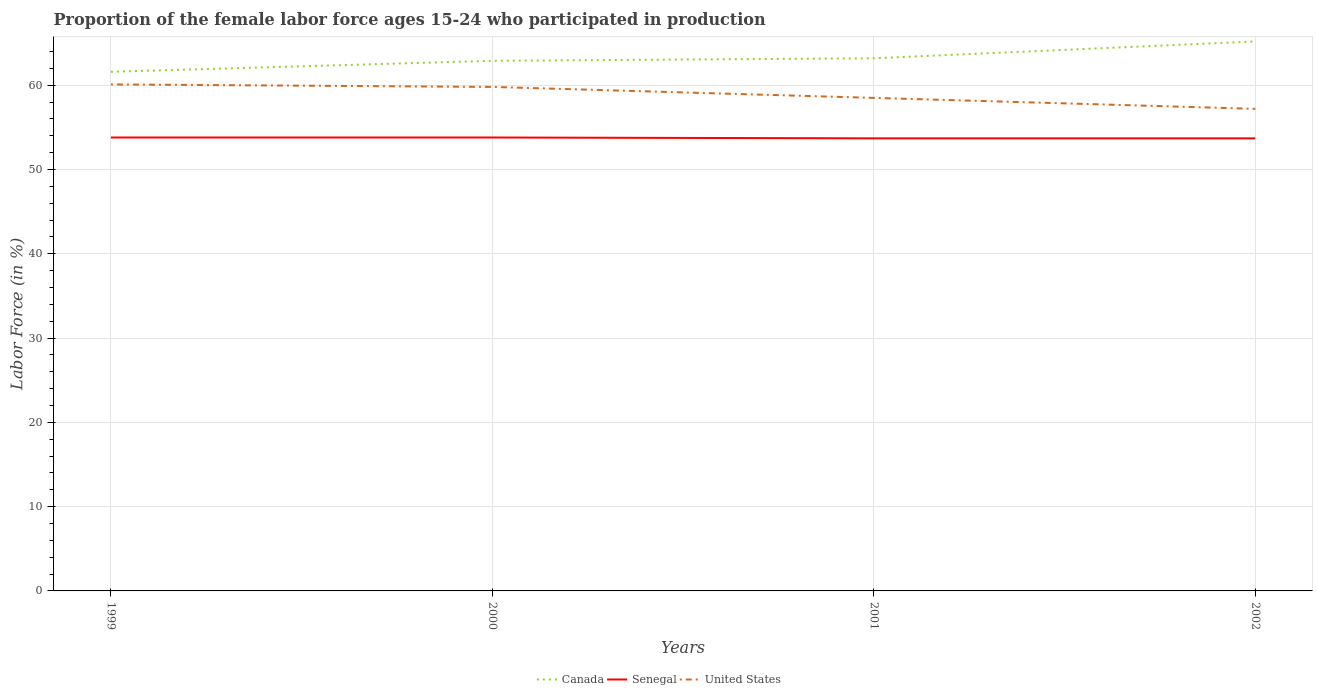Is the number of lines equal to the number of legend labels?
Offer a terse response. Yes. Across all years, what is the maximum proportion of the female labor force who participated in production in Canada?
Your answer should be very brief. 61.6. What is the total proportion of the female labor force who participated in production in Canada in the graph?
Offer a terse response. -0.3. What is the difference between the highest and the second highest proportion of the female labor force who participated in production in Canada?
Your answer should be very brief. 3.6. What is the difference between the highest and the lowest proportion of the female labor force who participated in production in United States?
Make the answer very short. 2. Is the proportion of the female labor force who participated in production in Senegal strictly greater than the proportion of the female labor force who participated in production in Canada over the years?
Provide a short and direct response. Yes. How many lines are there?
Provide a short and direct response. 3. What is the difference between two consecutive major ticks on the Y-axis?
Keep it short and to the point. 10. Are the values on the major ticks of Y-axis written in scientific E-notation?
Your answer should be compact. No. What is the title of the graph?
Provide a short and direct response. Proportion of the female labor force ages 15-24 who participated in production. Does "Poland" appear as one of the legend labels in the graph?
Provide a succinct answer. No. What is the label or title of the X-axis?
Offer a terse response. Years. What is the Labor Force (in %) of Canada in 1999?
Provide a succinct answer. 61.6. What is the Labor Force (in %) in Senegal in 1999?
Make the answer very short. 53.8. What is the Labor Force (in %) of United States in 1999?
Your answer should be compact. 60.1. What is the Labor Force (in %) of Canada in 2000?
Ensure brevity in your answer.  62.9. What is the Labor Force (in %) of Senegal in 2000?
Your answer should be very brief. 53.8. What is the Labor Force (in %) in United States in 2000?
Your response must be concise. 59.8. What is the Labor Force (in %) in Canada in 2001?
Ensure brevity in your answer.  63.2. What is the Labor Force (in %) of Senegal in 2001?
Make the answer very short. 53.7. What is the Labor Force (in %) in United States in 2001?
Make the answer very short. 58.5. What is the Labor Force (in %) of Canada in 2002?
Provide a short and direct response. 65.2. What is the Labor Force (in %) of Senegal in 2002?
Make the answer very short. 53.7. What is the Labor Force (in %) in United States in 2002?
Offer a very short reply. 57.2. Across all years, what is the maximum Labor Force (in %) of Canada?
Ensure brevity in your answer.  65.2. Across all years, what is the maximum Labor Force (in %) in Senegal?
Make the answer very short. 53.8. Across all years, what is the maximum Labor Force (in %) of United States?
Provide a short and direct response. 60.1. Across all years, what is the minimum Labor Force (in %) of Canada?
Keep it short and to the point. 61.6. Across all years, what is the minimum Labor Force (in %) in Senegal?
Provide a short and direct response. 53.7. Across all years, what is the minimum Labor Force (in %) in United States?
Make the answer very short. 57.2. What is the total Labor Force (in %) in Canada in the graph?
Make the answer very short. 252.9. What is the total Labor Force (in %) of Senegal in the graph?
Offer a terse response. 215. What is the total Labor Force (in %) in United States in the graph?
Offer a very short reply. 235.6. What is the difference between the Labor Force (in %) in Canada in 1999 and that in 2000?
Your answer should be compact. -1.3. What is the difference between the Labor Force (in %) of Senegal in 1999 and that in 2000?
Ensure brevity in your answer.  0. What is the difference between the Labor Force (in %) of Canada in 1999 and that in 2001?
Your response must be concise. -1.6. What is the difference between the Labor Force (in %) in United States in 1999 and that in 2001?
Your answer should be very brief. 1.6. What is the difference between the Labor Force (in %) of Senegal in 1999 and that in 2002?
Keep it short and to the point. 0.1. What is the difference between the Labor Force (in %) of Senegal in 2000 and that in 2001?
Provide a short and direct response. 0.1. What is the difference between the Labor Force (in %) in United States in 2000 and that in 2001?
Offer a terse response. 1.3. What is the difference between the Labor Force (in %) of Canada in 2000 and that in 2002?
Ensure brevity in your answer.  -2.3. What is the difference between the Labor Force (in %) in Senegal in 2000 and that in 2002?
Make the answer very short. 0.1. What is the difference between the Labor Force (in %) in United States in 2001 and that in 2002?
Give a very brief answer. 1.3. What is the difference between the Labor Force (in %) in Canada in 1999 and the Labor Force (in %) in United States in 2000?
Keep it short and to the point. 1.8. What is the difference between the Labor Force (in %) of Canada in 1999 and the Labor Force (in %) of United States in 2001?
Provide a short and direct response. 3.1. What is the difference between the Labor Force (in %) in Senegal in 1999 and the Labor Force (in %) in United States in 2001?
Your response must be concise. -4.7. What is the difference between the Labor Force (in %) of Canada in 1999 and the Labor Force (in %) of Senegal in 2002?
Provide a short and direct response. 7.9. What is the difference between the Labor Force (in %) of Canada in 2000 and the Labor Force (in %) of Senegal in 2001?
Offer a terse response. 9.2. What is the difference between the Labor Force (in %) of Canada in 2000 and the Labor Force (in %) of United States in 2001?
Offer a terse response. 4.4. What is the difference between the Labor Force (in %) in Senegal in 2000 and the Labor Force (in %) in United States in 2001?
Your response must be concise. -4.7. What is the difference between the Labor Force (in %) of Canada in 2000 and the Labor Force (in %) of Senegal in 2002?
Offer a terse response. 9.2. What is the difference between the Labor Force (in %) of Canada in 2001 and the Labor Force (in %) of Senegal in 2002?
Offer a terse response. 9.5. What is the difference between the Labor Force (in %) in Canada in 2001 and the Labor Force (in %) in United States in 2002?
Your response must be concise. 6. What is the average Labor Force (in %) of Canada per year?
Keep it short and to the point. 63.23. What is the average Labor Force (in %) of Senegal per year?
Your response must be concise. 53.75. What is the average Labor Force (in %) in United States per year?
Your answer should be compact. 58.9. In the year 1999, what is the difference between the Labor Force (in %) of Canada and Labor Force (in %) of United States?
Keep it short and to the point. 1.5. In the year 2000, what is the difference between the Labor Force (in %) in Canada and Labor Force (in %) in United States?
Offer a terse response. 3.1. In the year 2001, what is the difference between the Labor Force (in %) of Canada and Labor Force (in %) of Senegal?
Provide a short and direct response. 9.5. In the year 2001, what is the difference between the Labor Force (in %) of Canada and Labor Force (in %) of United States?
Your answer should be compact. 4.7. In the year 2002, what is the difference between the Labor Force (in %) of Canada and Labor Force (in %) of Senegal?
Give a very brief answer. 11.5. In the year 2002, what is the difference between the Labor Force (in %) of Canada and Labor Force (in %) of United States?
Provide a short and direct response. 8. What is the ratio of the Labor Force (in %) in Canada in 1999 to that in 2000?
Offer a terse response. 0.98. What is the ratio of the Labor Force (in %) in Canada in 1999 to that in 2001?
Give a very brief answer. 0.97. What is the ratio of the Labor Force (in %) of United States in 1999 to that in 2001?
Your response must be concise. 1.03. What is the ratio of the Labor Force (in %) of Canada in 1999 to that in 2002?
Offer a very short reply. 0.94. What is the ratio of the Labor Force (in %) of United States in 1999 to that in 2002?
Offer a terse response. 1.05. What is the ratio of the Labor Force (in %) of Canada in 2000 to that in 2001?
Make the answer very short. 1. What is the ratio of the Labor Force (in %) of Senegal in 2000 to that in 2001?
Your response must be concise. 1. What is the ratio of the Labor Force (in %) in United States in 2000 to that in 2001?
Your response must be concise. 1.02. What is the ratio of the Labor Force (in %) in Canada in 2000 to that in 2002?
Provide a short and direct response. 0.96. What is the ratio of the Labor Force (in %) in Senegal in 2000 to that in 2002?
Your response must be concise. 1. What is the ratio of the Labor Force (in %) in United States in 2000 to that in 2002?
Your answer should be compact. 1.05. What is the ratio of the Labor Force (in %) of Canada in 2001 to that in 2002?
Make the answer very short. 0.97. What is the ratio of the Labor Force (in %) of United States in 2001 to that in 2002?
Your answer should be compact. 1.02. What is the difference between the highest and the second highest Labor Force (in %) of Canada?
Offer a terse response. 2. What is the difference between the highest and the second highest Labor Force (in %) of United States?
Make the answer very short. 0.3. 